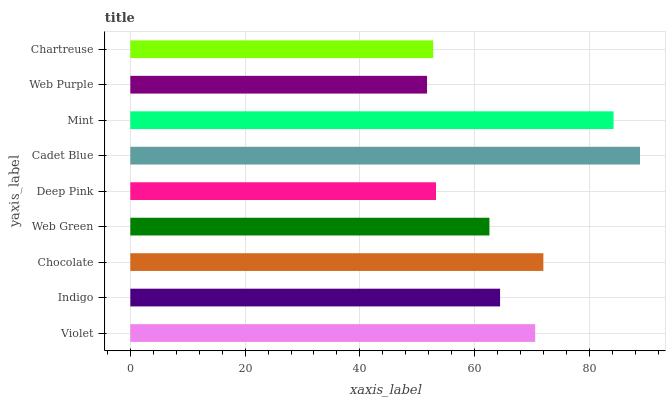Is Web Purple the minimum?
Answer yes or no. Yes. Is Cadet Blue the maximum?
Answer yes or no. Yes. Is Indigo the minimum?
Answer yes or no. No. Is Indigo the maximum?
Answer yes or no. No. Is Violet greater than Indigo?
Answer yes or no. Yes. Is Indigo less than Violet?
Answer yes or no. Yes. Is Indigo greater than Violet?
Answer yes or no. No. Is Violet less than Indigo?
Answer yes or no. No. Is Indigo the high median?
Answer yes or no. Yes. Is Indigo the low median?
Answer yes or no. Yes. Is Violet the high median?
Answer yes or no. No. Is Violet the low median?
Answer yes or no. No. 